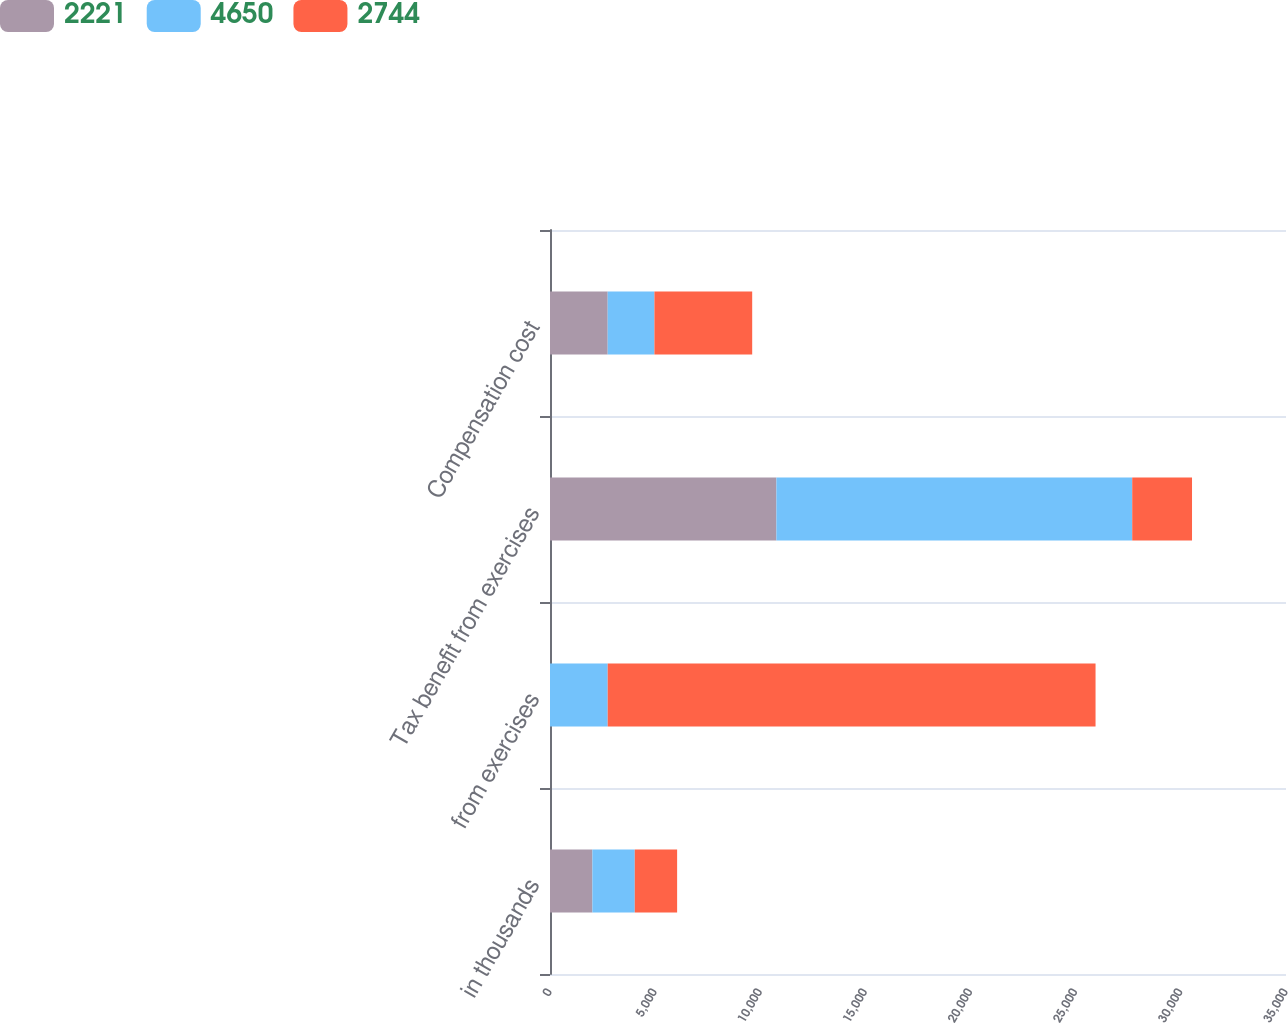Convert chart. <chart><loc_0><loc_0><loc_500><loc_500><stacked_bar_chart><ecel><fcel>in thousands<fcel>from exercises<fcel>Tax benefit from exercises<fcel>Compensation cost<nl><fcel>2221<fcel>2016<fcel>0<fcel>10767<fcel>2744<nl><fcel>4650<fcel>2015<fcel>2744<fcel>16920<fcel>2221<nl><fcel>2744<fcel>2014<fcel>23199<fcel>2844<fcel>4650<nl></chart> 